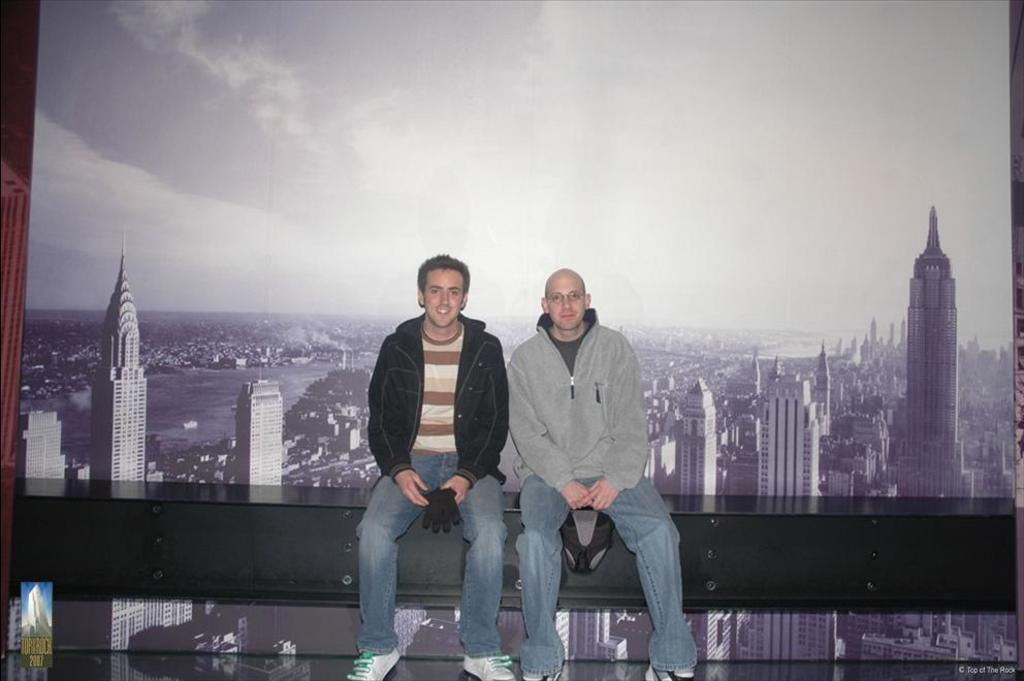What are the persons in the image doing? The persons in the image are sitting on an object. What type of structures can be seen in the background of the image? There are many buildings and skyscrapers in the image. What body of water is present in the image? There is a lake in the image. What part of the natural environment is visible in the image? The sky is visible in the image. What type of coal can be seen being transported on the lake in the image? There is no coal present in the image, and the lake does not show any transportation activity. 